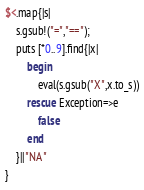Convert code to text. <code><loc_0><loc_0><loc_500><loc_500><_Ruby_>$<.map{|s|
    s.gsub!("=","==");
    puts [*0..9].find{|x|
		begin
			eval(s.gsub("X",x.to_s))
		rescue Exception=>e
			false
		end
	}||"NA"
}

</code> 